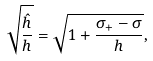Convert formula to latex. <formula><loc_0><loc_0><loc_500><loc_500>\sqrt { \frac { \hat { h } } { h } } = \sqrt { 1 + \frac { \sigma _ { + } - \sigma } { h } } ,</formula> 